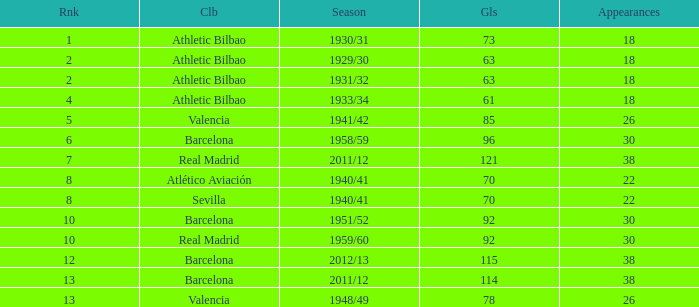Write the full table. {'header': ['Rnk', 'Clb', 'Season', 'Gls', 'Appearances'], 'rows': [['1', 'Athletic Bilbao', '1930/31', '73', '18'], ['2', 'Athletic Bilbao', '1929/30', '63', '18'], ['2', 'Athletic Bilbao', '1931/32', '63', '18'], ['4', 'Athletic Bilbao', '1933/34', '61', '18'], ['5', 'Valencia', '1941/42', '85', '26'], ['6', 'Barcelona', '1958/59', '96', '30'], ['7', 'Real Madrid', '2011/12', '121', '38'], ['8', 'Atlético Aviación', '1940/41', '70', '22'], ['8', 'Sevilla', '1940/41', '70', '22'], ['10', 'Barcelona', '1951/52', '92', '30'], ['10', 'Real Madrid', '1959/60', '92', '30'], ['12', 'Barcelona', '2012/13', '115', '38'], ['13', 'Barcelona', '2011/12', '114', '38'], ['13', 'Valencia', '1948/49', '78', '26']]} Which team participated in less than 22 events and held a position below 2nd place? Athletic Bilbao. 